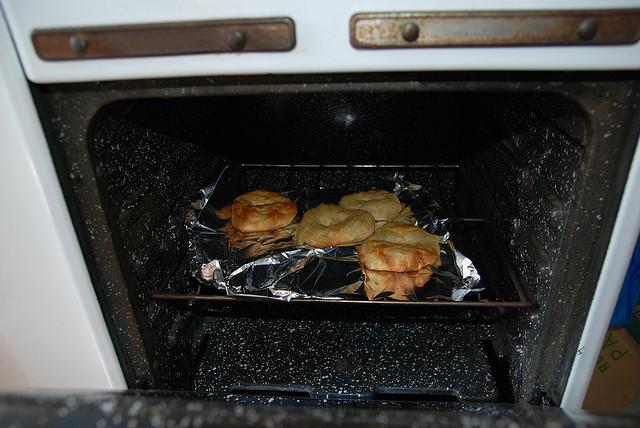What is safest to touch without being burned? foil 